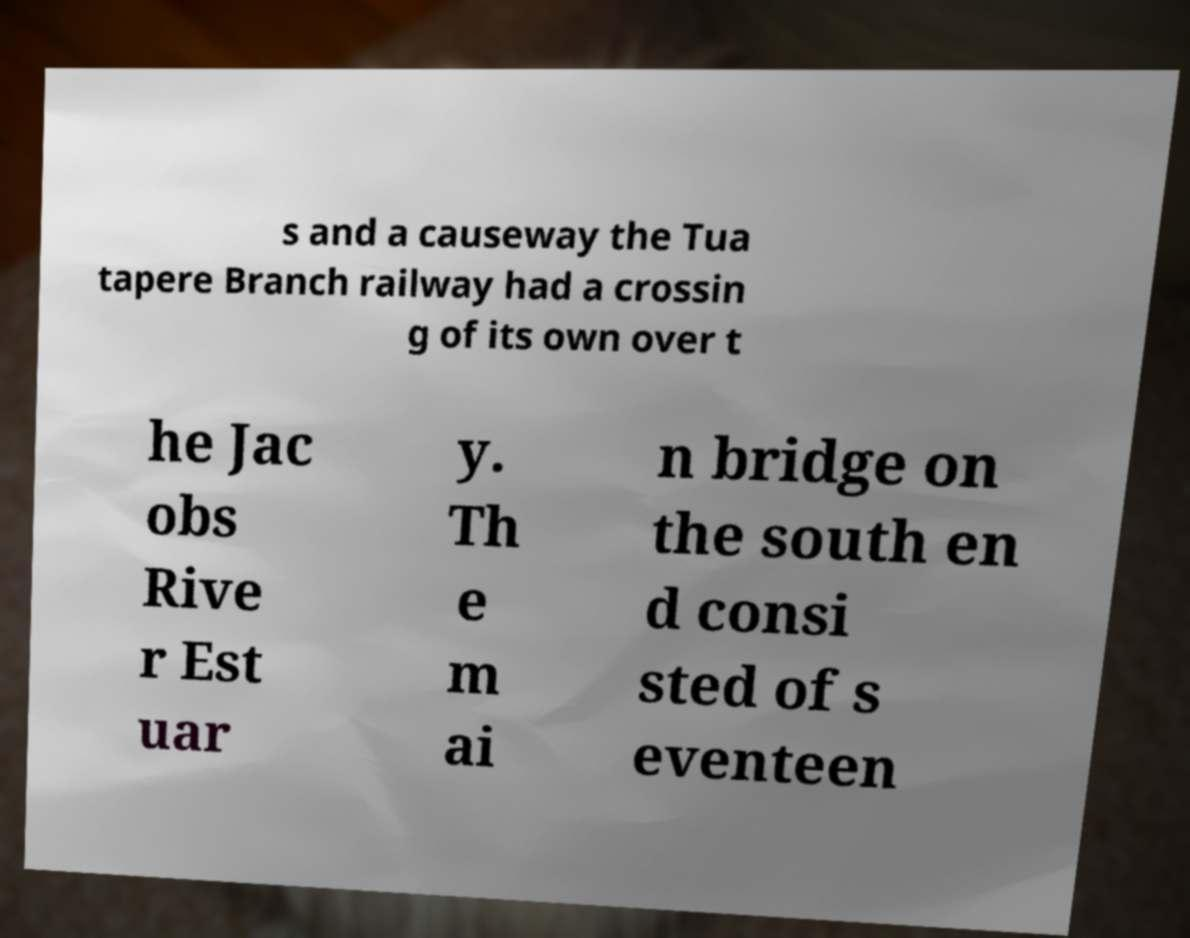What messages or text are displayed in this image? I need them in a readable, typed format. s and a causeway the Tua tapere Branch railway had a crossin g of its own over t he Jac obs Rive r Est uar y. Th e m ai n bridge on the south en d consi sted of s eventeen 